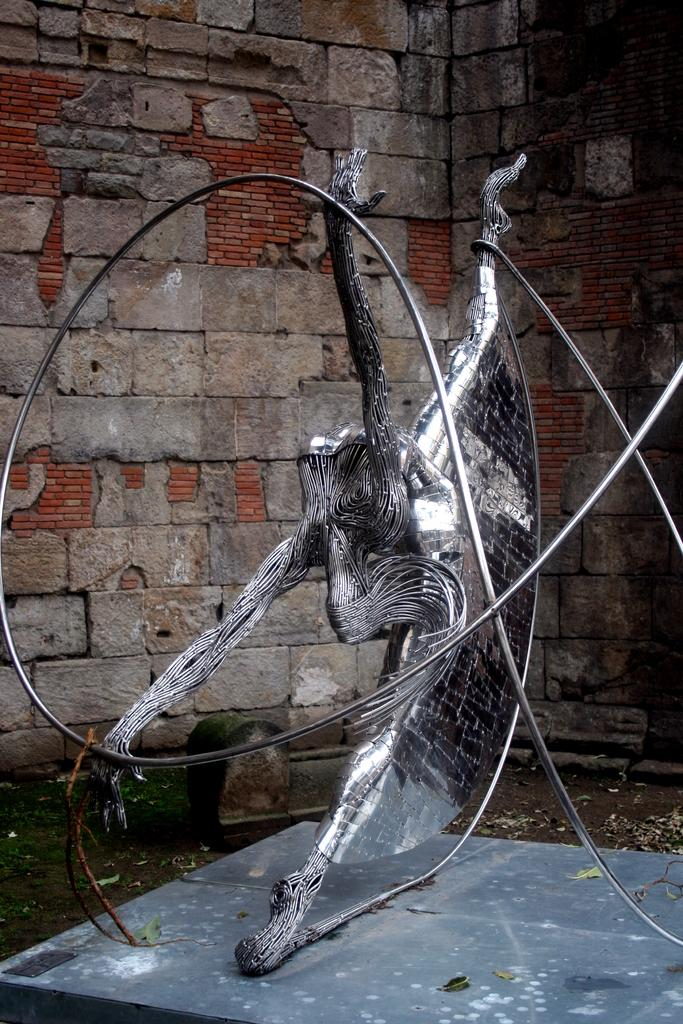What is the main object in the middle of the image? There is a metal object in the middle of the image. What can be seen in the background of the image? There is a wall in the background of the image. What type of furniture is being used for reading in the image? There is no furniture or reading activity present in the image; it only features a metal object and a wall in the background. 